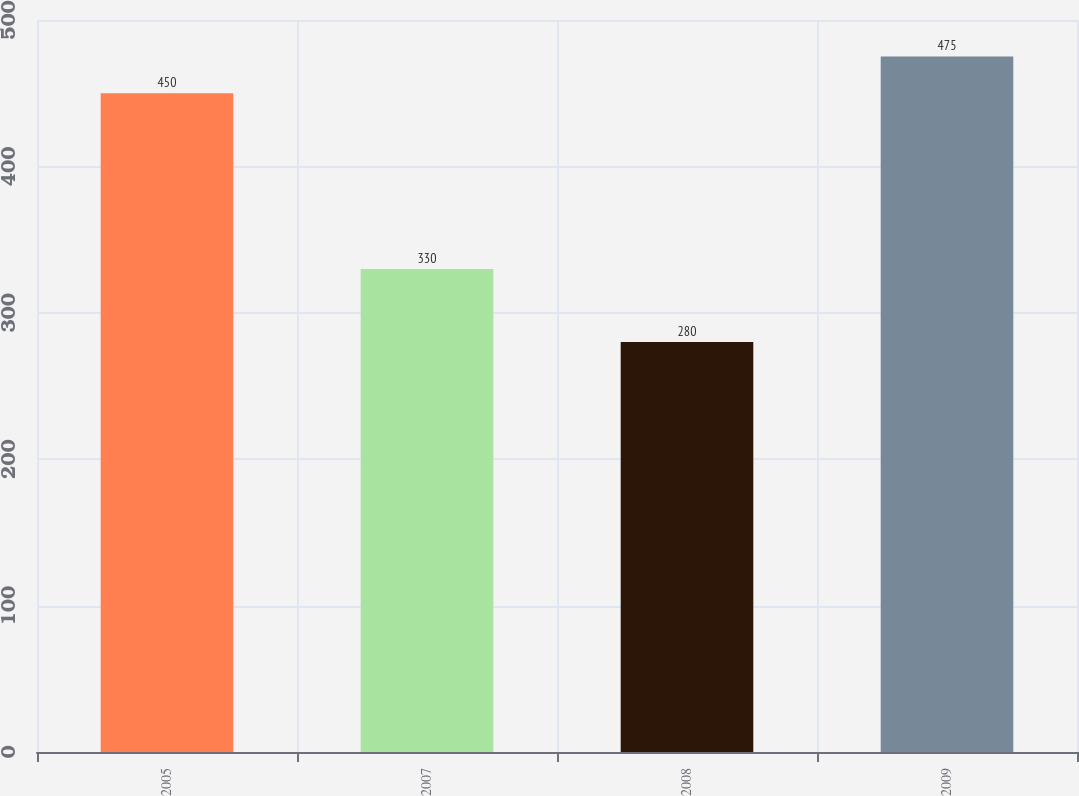Convert chart. <chart><loc_0><loc_0><loc_500><loc_500><bar_chart><fcel>2005<fcel>2007<fcel>2008<fcel>2009<nl><fcel>450<fcel>330<fcel>280<fcel>475<nl></chart> 